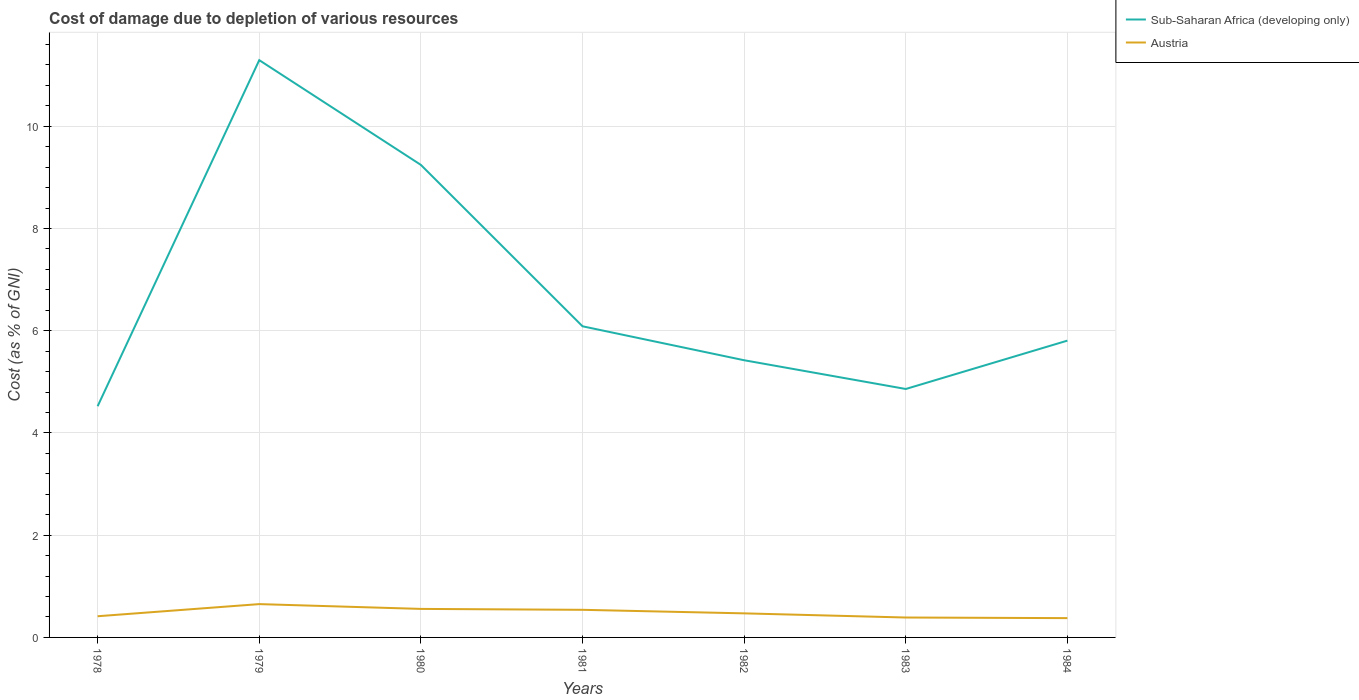Does the line corresponding to Austria intersect with the line corresponding to Sub-Saharan Africa (developing only)?
Make the answer very short. No. Is the number of lines equal to the number of legend labels?
Ensure brevity in your answer.  Yes. Across all years, what is the maximum cost of damage caused due to the depletion of various resources in Sub-Saharan Africa (developing only)?
Provide a succinct answer. 4.52. What is the total cost of damage caused due to the depletion of various resources in Austria in the graph?
Ensure brevity in your answer.  -0.06. What is the difference between the highest and the second highest cost of damage caused due to the depletion of various resources in Austria?
Your answer should be compact. 0.27. Is the cost of damage caused due to the depletion of various resources in Sub-Saharan Africa (developing only) strictly greater than the cost of damage caused due to the depletion of various resources in Austria over the years?
Your answer should be compact. No. Are the values on the major ticks of Y-axis written in scientific E-notation?
Offer a terse response. No. Does the graph contain grids?
Offer a very short reply. Yes. How are the legend labels stacked?
Make the answer very short. Vertical. What is the title of the graph?
Ensure brevity in your answer.  Cost of damage due to depletion of various resources. Does "St. Vincent and the Grenadines" appear as one of the legend labels in the graph?
Your answer should be very brief. No. What is the label or title of the Y-axis?
Your answer should be very brief. Cost (as % of GNI). What is the Cost (as % of GNI) in Sub-Saharan Africa (developing only) in 1978?
Offer a terse response. 4.52. What is the Cost (as % of GNI) of Austria in 1978?
Give a very brief answer. 0.41. What is the Cost (as % of GNI) of Sub-Saharan Africa (developing only) in 1979?
Make the answer very short. 11.29. What is the Cost (as % of GNI) of Austria in 1979?
Offer a very short reply. 0.65. What is the Cost (as % of GNI) of Sub-Saharan Africa (developing only) in 1980?
Offer a terse response. 9.24. What is the Cost (as % of GNI) in Austria in 1980?
Offer a terse response. 0.56. What is the Cost (as % of GNI) of Sub-Saharan Africa (developing only) in 1981?
Keep it short and to the point. 6.09. What is the Cost (as % of GNI) in Austria in 1981?
Your answer should be very brief. 0.54. What is the Cost (as % of GNI) of Sub-Saharan Africa (developing only) in 1982?
Make the answer very short. 5.42. What is the Cost (as % of GNI) of Austria in 1982?
Offer a very short reply. 0.47. What is the Cost (as % of GNI) in Sub-Saharan Africa (developing only) in 1983?
Provide a short and direct response. 4.86. What is the Cost (as % of GNI) of Austria in 1983?
Your answer should be very brief. 0.39. What is the Cost (as % of GNI) in Sub-Saharan Africa (developing only) in 1984?
Offer a very short reply. 5.81. What is the Cost (as % of GNI) in Austria in 1984?
Offer a very short reply. 0.38. Across all years, what is the maximum Cost (as % of GNI) of Sub-Saharan Africa (developing only)?
Ensure brevity in your answer.  11.29. Across all years, what is the maximum Cost (as % of GNI) in Austria?
Provide a succinct answer. 0.65. Across all years, what is the minimum Cost (as % of GNI) of Sub-Saharan Africa (developing only)?
Your answer should be compact. 4.52. Across all years, what is the minimum Cost (as % of GNI) in Austria?
Make the answer very short. 0.38. What is the total Cost (as % of GNI) of Sub-Saharan Africa (developing only) in the graph?
Provide a short and direct response. 47.23. What is the total Cost (as % of GNI) of Austria in the graph?
Give a very brief answer. 3.4. What is the difference between the Cost (as % of GNI) in Sub-Saharan Africa (developing only) in 1978 and that in 1979?
Offer a terse response. -6.77. What is the difference between the Cost (as % of GNI) in Austria in 1978 and that in 1979?
Your answer should be very brief. -0.24. What is the difference between the Cost (as % of GNI) of Sub-Saharan Africa (developing only) in 1978 and that in 1980?
Make the answer very short. -4.72. What is the difference between the Cost (as % of GNI) in Austria in 1978 and that in 1980?
Offer a terse response. -0.14. What is the difference between the Cost (as % of GNI) in Sub-Saharan Africa (developing only) in 1978 and that in 1981?
Your answer should be compact. -1.56. What is the difference between the Cost (as % of GNI) in Austria in 1978 and that in 1981?
Your answer should be compact. -0.13. What is the difference between the Cost (as % of GNI) of Sub-Saharan Africa (developing only) in 1978 and that in 1982?
Your answer should be compact. -0.9. What is the difference between the Cost (as % of GNI) of Austria in 1978 and that in 1982?
Provide a short and direct response. -0.06. What is the difference between the Cost (as % of GNI) in Sub-Saharan Africa (developing only) in 1978 and that in 1983?
Offer a terse response. -0.34. What is the difference between the Cost (as % of GNI) of Austria in 1978 and that in 1983?
Provide a succinct answer. 0.03. What is the difference between the Cost (as % of GNI) in Sub-Saharan Africa (developing only) in 1978 and that in 1984?
Offer a very short reply. -1.28. What is the difference between the Cost (as % of GNI) in Austria in 1978 and that in 1984?
Keep it short and to the point. 0.04. What is the difference between the Cost (as % of GNI) of Sub-Saharan Africa (developing only) in 1979 and that in 1980?
Offer a very short reply. 2.05. What is the difference between the Cost (as % of GNI) of Austria in 1979 and that in 1980?
Ensure brevity in your answer.  0.09. What is the difference between the Cost (as % of GNI) of Sub-Saharan Africa (developing only) in 1979 and that in 1981?
Ensure brevity in your answer.  5.21. What is the difference between the Cost (as % of GNI) of Austria in 1979 and that in 1981?
Ensure brevity in your answer.  0.11. What is the difference between the Cost (as % of GNI) of Sub-Saharan Africa (developing only) in 1979 and that in 1982?
Your answer should be very brief. 5.87. What is the difference between the Cost (as % of GNI) of Austria in 1979 and that in 1982?
Your answer should be very brief. 0.18. What is the difference between the Cost (as % of GNI) of Sub-Saharan Africa (developing only) in 1979 and that in 1983?
Keep it short and to the point. 6.43. What is the difference between the Cost (as % of GNI) of Austria in 1979 and that in 1983?
Keep it short and to the point. 0.26. What is the difference between the Cost (as % of GNI) in Sub-Saharan Africa (developing only) in 1979 and that in 1984?
Keep it short and to the point. 5.49. What is the difference between the Cost (as % of GNI) in Austria in 1979 and that in 1984?
Your answer should be compact. 0.27. What is the difference between the Cost (as % of GNI) in Sub-Saharan Africa (developing only) in 1980 and that in 1981?
Provide a succinct answer. 3.16. What is the difference between the Cost (as % of GNI) in Austria in 1980 and that in 1981?
Provide a succinct answer. 0.02. What is the difference between the Cost (as % of GNI) of Sub-Saharan Africa (developing only) in 1980 and that in 1982?
Give a very brief answer. 3.82. What is the difference between the Cost (as % of GNI) of Austria in 1980 and that in 1982?
Your answer should be very brief. 0.09. What is the difference between the Cost (as % of GNI) in Sub-Saharan Africa (developing only) in 1980 and that in 1983?
Offer a very short reply. 4.38. What is the difference between the Cost (as % of GNI) of Austria in 1980 and that in 1983?
Offer a terse response. 0.17. What is the difference between the Cost (as % of GNI) in Sub-Saharan Africa (developing only) in 1980 and that in 1984?
Your response must be concise. 3.44. What is the difference between the Cost (as % of GNI) in Austria in 1980 and that in 1984?
Your answer should be very brief. 0.18. What is the difference between the Cost (as % of GNI) of Sub-Saharan Africa (developing only) in 1981 and that in 1982?
Provide a short and direct response. 0.66. What is the difference between the Cost (as % of GNI) in Austria in 1981 and that in 1982?
Make the answer very short. 0.07. What is the difference between the Cost (as % of GNI) in Sub-Saharan Africa (developing only) in 1981 and that in 1983?
Your response must be concise. 1.23. What is the difference between the Cost (as % of GNI) in Austria in 1981 and that in 1983?
Provide a short and direct response. 0.15. What is the difference between the Cost (as % of GNI) in Sub-Saharan Africa (developing only) in 1981 and that in 1984?
Your answer should be compact. 0.28. What is the difference between the Cost (as % of GNI) in Austria in 1981 and that in 1984?
Your response must be concise. 0.16. What is the difference between the Cost (as % of GNI) of Sub-Saharan Africa (developing only) in 1982 and that in 1983?
Offer a very short reply. 0.56. What is the difference between the Cost (as % of GNI) of Austria in 1982 and that in 1983?
Provide a short and direct response. 0.08. What is the difference between the Cost (as % of GNI) of Sub-Saharan Africa (developing only) in 1982 and that in 1984?
Make the answer very short. -0.38. What is the difference between the Cost (as % of GNI) in Austria in 1982 and that in 1984?
Make the answer very short. 0.09. What is the difference between the Cost (as % of GNI) of Sub-Saharan Africa (developing only) in 1983 and that in 1984?
Your answer should be compact. -0.95. What is the difference between the Cost (as % of GNI) in Austria in 1983 and that in 1984?
Your response must be concise. 0.01. What is the difference between the Cost (as % of GNI) of Sub-Saharan Africa (developing only) in 1978 and the Cost (as % of GNI) of Austria in 1979?
Your answer should be compact. 3.87. What is the difference between the Cost (as % of GNI) of Sub-Saharan Africa (developing only) in 1978 and the Cost (as % of GNI) of Austria in 1980?
Make the answer very short. 3.96. What is the difference between the Cost (as % of GNI) of Sub-Saharan Africa (developing only) in 1978 and the Cost (as % of GNI) of Austria in 1981?
Your response must be concise. 3.98. What is the difference between the Cost (as % of GNI) of Sub-Saharan Africa (developing only) in 1978 and the Cost (as % of GNI) of Austria in 1982?
Ensure brevity in your answer.  4.05. What is the difference between the Cost (as % of GNI) of Sub-Saharan Africa (developing only) in 1978 and the Cost (as % of GNI) of Austria in 1983?
Give a very brief answer. 4.13. What is the difference between the Cost (as % of GNI) in Sub-Saharan Africa (developing only) in 1978 and the Cost (as % of GNI) in Austria in 1984?
Make the answer very short. 4.15. What is the difference between the Cost (as % of GNI) of Sub-Saharan Africa (developing only) in 1979 and the Cost (as % of GNI) of Austria in 1980?
Your answer should be very brief. 10.73. What is the difference between the Cost (as % of GNI) in Sub-Saharan Africa (developing only) in 1979 and the Cost (as % of GNI) in Austria in 1981?
Provide a succinct answer. 10.75. What is the difference between the Cost (as % of GNI) of Sub-Saharan Africa (developing only) in 1979 and the Cost (as % of GNI) of Austria in 1982?
Make the answer very short. 10.82. What is the difference between the Cost (as % of GNI) of Sub-Saharan Africa (developing only) in 1979 and the Cost (as % of GNI) of Austria in 1983?
Your response must be concise. 10.9. What is the difference between the Cost (as % of GNI) of Sub-Saharan Africa (developing only) in 1979 and the Cost (as % of GNI) of Austria in 1984?
Offer a very short reply. 10.92. What is the difference between the Cost (as % of GNI) in Sub-Saharan Africa (developing only) in 1980 and the Cost (as % of GNI) in Austria in 1981?
Your response must be concise. 8.7. What is the difference between the Cost (as % of GNI) of Sub-Saharan Africa (developing only) in 1980 and the Cost (as % of GNI) of Austria in 1982?
Your response must be concise. 8.77. What is the difference between the Cost (as % of GNI) of Sub-Saharan Africa (developing only) in 1980 and the Cost (as % of GNI) of Austria in 1983?
Your answer should be very brief. 8.85. What is the difference between the Cost (as % of GNI) in Sub-Saharan Africa (developing only) in 1980 and the Cost (as % of GNI) in Austria in 1984?
Ensure brevity in your answer.  8.87. What is the difference between the Cost (as % of GNI) in Sub-Saharan Africa (developing only) in 1981 and the Cost (as % of GNI) in Austria in 1982?
Keep it short and to the point. 5.62. What is the difference between the Cost (as % of GNI) of Sub-Saharan Africa (developing only) in 1981 and the Cost (as % of GNI) of Austria in 1983?
Offer a terse response. 5.7. What is the difference between the Cost (as % of GNI) of Sub-Saharan Africa (developing only) in 1981 and the Cost (as % of GNI) of Austria in 1984?
Provide a short and direct response. 5.71. What is the difference between the Cost (as % of GNI) in Sub-Saharan Africa (developing only) in 1982 and the Cost (as % of GNI) in Austria in 1983?
Your response must be concise. 5.03. What is the difference between the Cost (as % of GNI) of Sub-Saharan Africa (developing only) in 1982 and the Cost (as % of GNI) of Austria in 1984?
Your answer should be very brief. 5.04. What is the difference between the Cost (as % of GNI) in Sub-Saharan Africa (developing only) in 1983 and the Cost (as % of GNI) in Austria in 1984?
Provide a succinct answer. 4.48. What is the average Cost (as % of GNI) in Sub-Saharan Africa (developing only) per year?
Keep it short and to the point. 6.75. What is the average Cost (as % of GNI) of Austria per year?
Give a very brief answer. 0.49. In the year 1978, what is the difference between the Cost (as % of GNI) of Sub-Saharan Africa (developing only) and Cost (as % of GNI) of Austria?
Offer a very short reply. 4.11. In the year 1979, what is the difference between the Cost (as % of GNI) of Sub-Saharan Africa (developing only) and Cost (as % of GNI) of Austria?
Provide a short and direct response. 10.64. In the year 1980, what is the difference between the Cost (as % of GNI) in Sub-Saharan Africa (developing only) and Cost (as % of GNI) in Austria?
Keep it short and to the point. 8.69. In the year 1981, what is the difference between the Cost (as % of GNI) of Sub-Saharan Africa (developing only) and Cost (as % of GNI) of Austria?
Give a very brief answer. 5.55. In the year 1982, what is the difference between the Cost (as % of GNI) of Sub-Saharan Africa (developing only) and Cost (as % of GNI) of Austria?
Your answer should be very brief. 4.95. In the year 1983, what is the difference between the Cost (as % of GNI) of Sub-Saharan Africa (developing only) and Cost (as % of GNI) of Austria?
Offer a very short reply. 4.47. In the year 1984, what is the difference between the Cost (as % of GNI) of Sub-Saharan Africa (developing only) and Cost (as % of GNI) of Austria?
Your answer should be very brief. 5.43. What is the ratio of the Cost (as % of GNI) of Sub-Saharan Africa (developing only) in 1978 to that in 1979?
Your answer should be compact. 0.4. What is the ratio of the Cost (as % of GNI) in Austria in 1978 to that in 1979?
Provide a short and direct response. 0.64. What is the ratio of the Cost (as % of GNI) of Sub-Saharan Africa (developing only) in 1978 to that in 1980?
Your answer should be very brief. 0.49. What is the ratio of the Cost (as % of GNI) in Austria in 1978 to that in 1980?
Give a very brief answer. 0.74. What is the ratio of the Cost (as % of GNI) in Sub-Saharan Africa (developing only) in 1978 to that in 1981?
Your answer should be compact. 0.74. What is the ratio of the Cost (as % of GNI) of Austria in 1978 to that in 1981?
Provide a short and direct response. 0.77. What is the ratio of the Cost (as % of GNI) of Sub-Saharan Africa (developing only) in 1978 to that in 1982?
Offer a very short reply. 0.83. What is the ratio of the Cost (as % of GNI) in Austria in 1978 to that in 1982?
Your answer should be compact. 0.88. What is the ratio of the Cost (as % of GNI) in Sub-Saharan Africa (developing only) in 1978 to that in 1983?
Provide a succinct answer. 0.93. What is the ratio of the Cost (as % of GNI) of Austria in 1978 to that in 1983?
Ensure brevity in your answer.  1.06. What is the ratio of the Cost (as % of GNI) of Sub-Saharan Africa (developing only) in 1978 to that in 1984?
Keep it short and to the point. 0.78. What is the ratio of the Cost (as % of GNI) in Austria in 1978 to that in 1984?
Make the answer very short. 1.1. What is the ratio of the Cost (as % of GNI) of Sub-Saharan Africa (developing only) in 1979 to that in 1980?
Offer a very short reply. 1.22. What is the ratio of the Cost (as % of GNI) of Austria in 1979 to that in 1980?
Your answer should be very brief. 1.17. What is the ratio of the Cost (as % of GNI) in Sub-Saharan Africa (developing only) in 1979 to that in 1981?
Offer a very short reply. 1.86. What is the ratio of the Cost (as % of GNI) of Austria in 1979 to that in 1981?
Give a very brief answer. 1.21. What is the ratio of the Cost (as % of GNI) in Sub-Saharan Africa (developing only) in 1979 to that in 1982?
Offer a terse response. 2.08. What is the ratio of the Cost (as % of GNI) in Austria in 1979 to that in 1982?
Provide a short and direct response. 1.38. What is the ratio of the Cost (as % of GNI) of Sub-Saharan Africa (developing only) in 1979 to that in 1983?
Keep it short and to the point. 2.32. What is the ratio of the Cost (as % of GNI) in Austria in 1979 to that in 1983?
Provide a short and direct response. 1.67. What is the ratio of the Cost (as % of GNI) of Sub-Saharan Africa (developing only) in 1979 to that in 1984?
Provide a short and direct response. 1.95. What is the ratio of the Cost (as % of GNI) of Austria in 1979 to that in 1984?
Make the answer very short. 1.73. What is the ratio of the Cost (as % of GNI) of Sub-Saharan Africa (developing only) in 1980 to that in 1981?
Provide a succinct answer. 1.52. What is the ratio of the Cost (as % of GNI) in Austria in 1980 to that in 1981?
Make the answer very short. 1.03. What is the ratio of the Cost (as % of GNI) in Sub-Saharan Africa (developing only) in 1980 to that in 1982?
Make the answer very short. 1.7. What is the ratio of the Cost (as % of GNI) of Austria in 1980 to that in 1982?
Offer a terse response. 1.18. What is the ratio of the Cost (as % of GNI) of Sub-Saharan Africa (developing only) in 1980 to that in 1983?
Make the answer very short. 1.9. What is the ratio of the Cost (as % of GNI) of Austria in 1980 to that in 1983?
Your answer should be compact. 1.43. What is the ratio of the Cost (as % of GNI) of Sub-Saharan Africa (developing only) in 1980 to that in 1984?
Provide a succinct answer. 1.59. What is the ratio of the Cost (as % of GNI) of Austria in 1980 to that in 1984?
Keep it short and to the point. 1.48. What is the ratio of the Cost (as % of GNI) of Sub-Saharan Africa (developing only) in 1981 to that in 1982?
Give a very brief answer. 1.12. What is the ratio of the Cost (as % of GNI) of Austria in 1981 to that in 1982?
Offer a very short reply. 1.15. What is the ratio of the Cost (as % of GNI) of Sub-Saharan Africa (developing only) in 1981 to that in 1983?
Offer a very short reply. 1.25. What is the ratio of the Cost (as % of GNI) in Austria in 1981 to that in 1983?
Ensure brevity in your answer.  1.39. What is the ratio of the Cost (as % of GNI) of Sub-Saharan Africa (developing only) in 1981 to that in 1984?
Your answer should be compact. 1.05. What is the ratio of the Cost (as % of GNI) in Austria in 1981 to that in 1984?
Offer a very short reply. 1.43. What is the ratio of the Cost (as % of GNI) in Sub-Saharan Africa (developing only) in 1982 to that in 1983?
Your answer should be very brief. 1.12. What is the ratio of the Cost (as % of GNI) in Austria in 1982 to that in 1983?
Offer a very short reply. 1.21. What is the ratio of the Cost (as % of GNI) of Sub-Saharan Africa (developing only) in 1982 to that in 1984?
Provide a succinct answer. 0.93. What is the ratio of the Cost (as % of GNI) of Austria in 1982 to that in 1984?
Your answer should be very brief. 1.25. What is the ratio of the Cost (as % of GNI) in Sub-Saharan Africa (developing only) in 1983 to that in 1984?
Give a very brief answer. 0.84. What is the ratio of the Cost (as % of GNI) in Austria in 1983 to that in 1984?
Your answer should be compact. 1.03. What is the difference between the highest and the second highest Cost (as % of GNI) in Sub-Saharan Africa (developing only)?
Ensure brevity in your answer.  2.05. What is the difference between the highest and the second highest Cost (as % of GNI) in Austria?
Give a very brief answer. 0.09. What is the difference between the highest and the lowest Cost (as % of GNI) of Sub-Saharan Africa (developing only)?
Give a very brief answer. 6.77. What is the difference between the highest and the lowest Cost (as % of GNI) in Austria?
Keep it short and to the point. 0.27. 